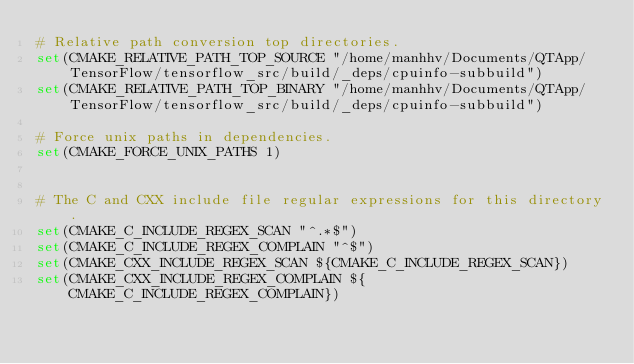Convert code to text. <code><loc_0><loc_0><loc_500><loc_500><_CMake_># Relative path conversion top directories.
set(CMAKE_RELATIVE_PATH_TOP_SOURCE "/home/manhhv/Documents/QTApp/TensorFlow/tensorflow_src/build/_deps/cpuinfo-subbuild")
set(CMAKE_RELATIVE_PATH_TOP_BINARY "/home/manhhv/Documents/QTApp/TensorFlow/tensorflow_src/build/_deps/cpuinfo-subbuild")

# Force unix paths in dependencies.
set(CMAKE_FORCE_UNIX_PATHS 1)


# The C and CXX include file regular expressions for this directory.
set(CMAKE_C_INCLUDE_REGEX_SCAN "^.*$")
set(CMAKE_C_INCLUDE_REGEX_COMPLAIN "^$")
set(CMAKE_CXX_INCLUDE_REGEX_SCAN ${CMAKE_C_INCLUDE_REGEX_SCAN})
set(CMAKE_CXX_INCLUDE_REGEX_COMPLAIN ${CMAKE_C_INCLUDE_REGEX_COMPLAIN})
</code> 